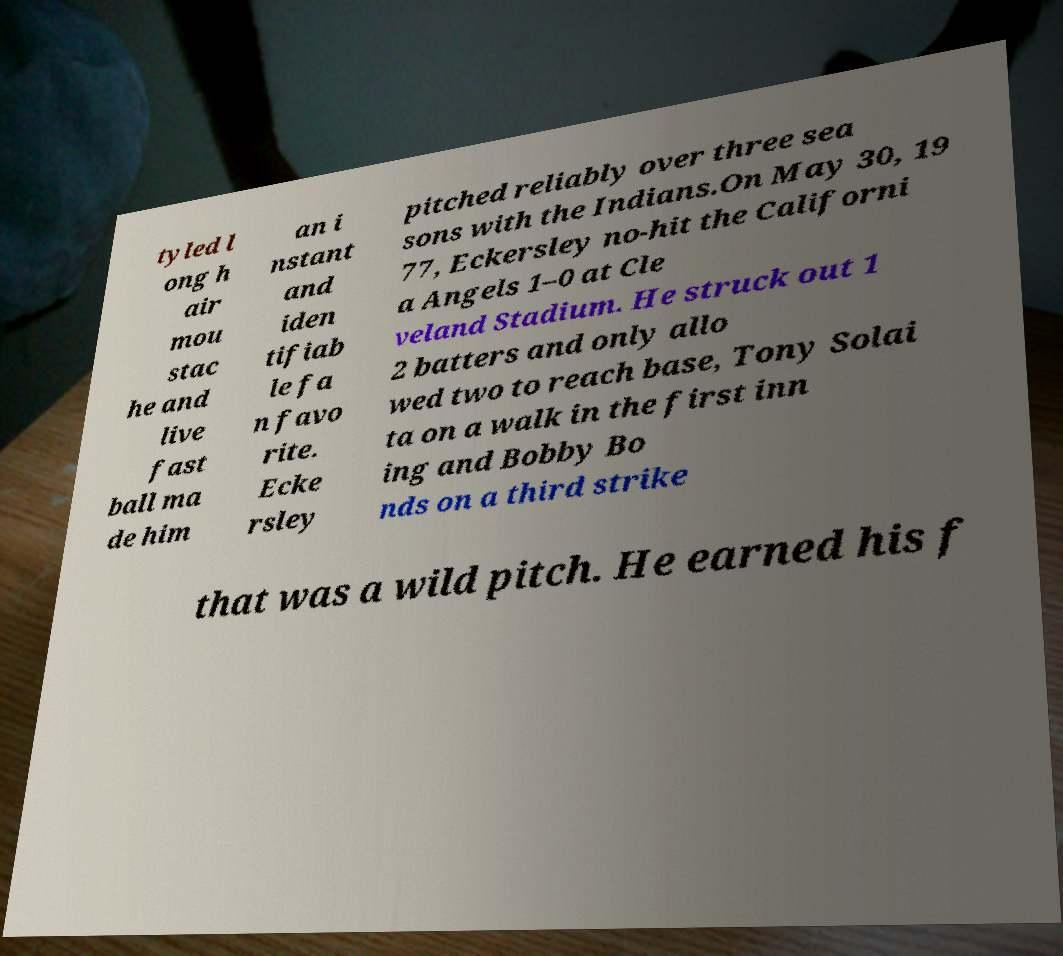I need the written content from this picture converted into text. Can you do that? tyled l ong h air mou stac he and live fast ball ma de him an i nstant and iden tifiab le fa n favo rite. Ecke rsley pitched reliably over three sea sons with the Indians.On May 30, 19 77, Eckersley no-hit the Californi a Angels 1–0 at Cle veland Stadium. He struck out 1 2 batters and only allo wed two to reach base, Tony Solai ta on a walk in the first inn ing and Bobby Bo nds on a third strike that was a wild pitch. He earned his f 